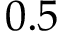Convert formula to latex. <formula><loc_0><loc_0><loc_500><loc_500>0 . 5</formula> 